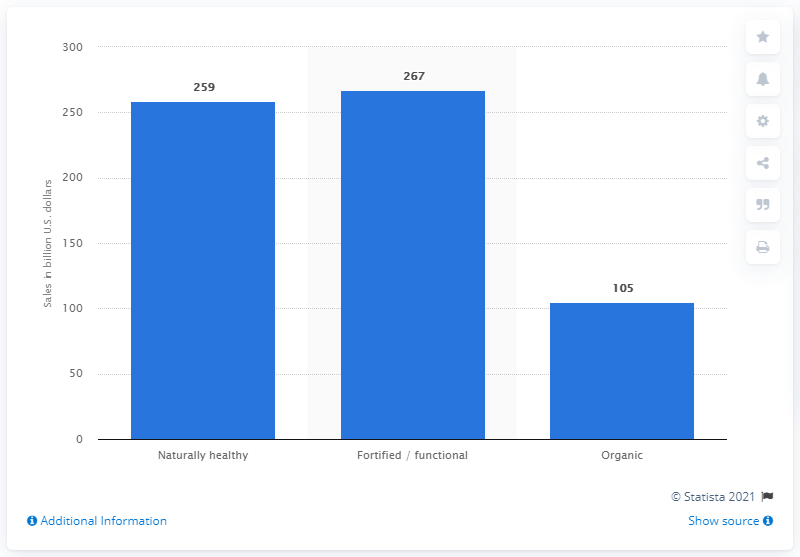Highlight a few significant elements in this photo. In the United States in 2020, organic food and beverage sales reached a total of $105 billion. 